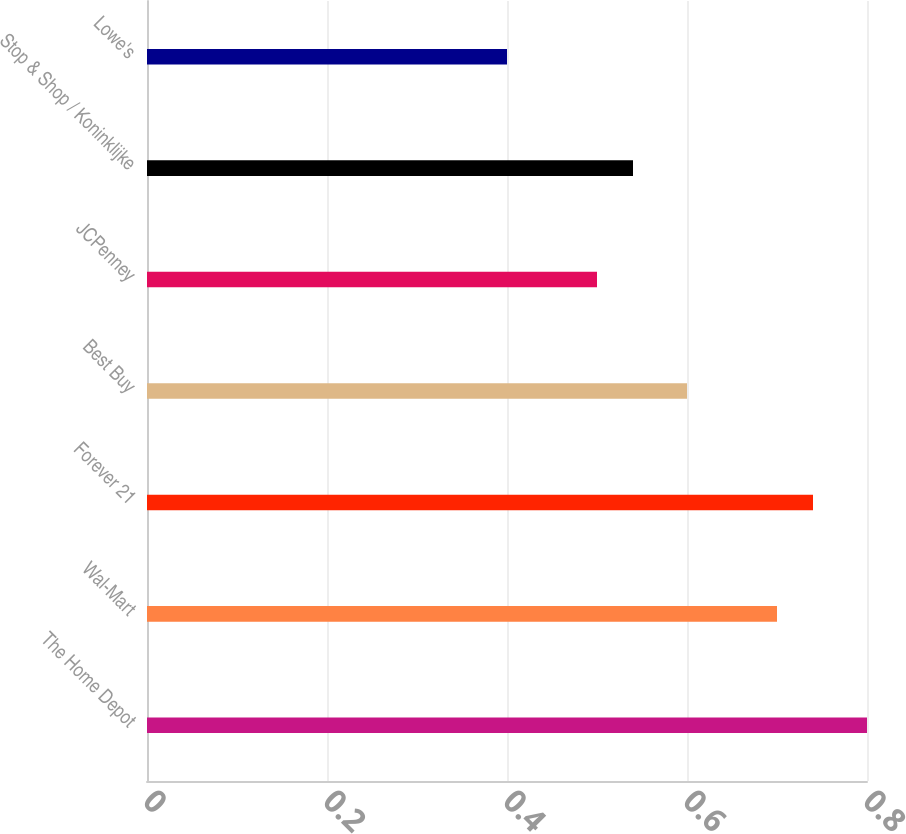Convert chart. <chart><loc_0><loc_0><loc_500><loc_500><bar_chart><fcel>The Home Depot<fcel>Wal-Mart<fcel>Forever 21<fcel>Best Buy<fcel>JCPenney<fcel>Stop & Shop / Koninklijke<fcel>Lowe's<nl><fcel>0.8<fcel>0.7<fcel>0.74<fcel>0.6<fcel>0.5<fcel>0.54<fcel>0.4<nl></chart> 